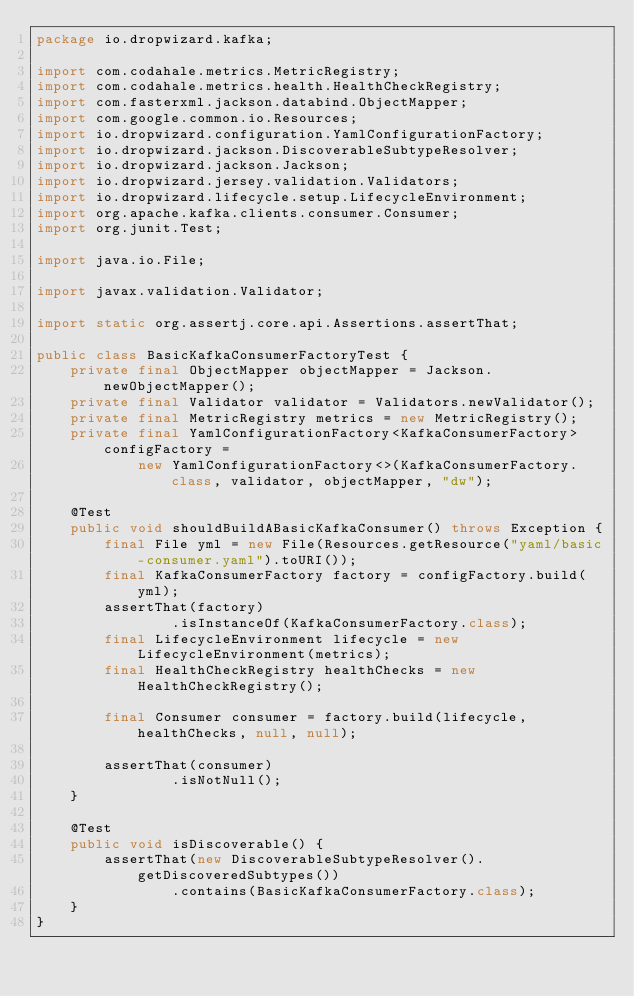Convert code to text. <code><loc_0><loc_0><loc_500><loc_500><_Java_>package io.dropwizard.kafka;

import com.codahale.metrics.MetricRegistry;
import com.codahale.metrics.health.HealthCheckRegistry;
import com.fasterxml.jackson.databind.ObjectMapper;
import com.google.common.io.Resources;
import io.dropwizard.configuration.YamlConfigurationFactory;
import io.dropwizard.jackson.DiscoverableSubtypeResolver;
import io.dropwizard.jackson.Jackson;
import io.dropwizard.jersey.validation.Validators;
import io.dropwizard.lifecycle.setup.LifecycleEnvironment;
import org.apache.kafka.clients.consumer.Consumer;
import org.junit.Test;

import java.io.File;

import javax.validation.Validator;

import static org.assertj.core.api.Assertions.assertThat;

public class BasicKafkaConsumerFactoryTest {
    private final ObjectMapper objectMapper = Jackson.newObjectMapper();
    private final Validator validator = Validators.newValidator();
    private final MetricRegistry metrics = new MetricRegistry();
    private final YamlConfigurationFactory<KafkaConsumerFactory> configFactory =
            new YamlConfigurationFactory<>(KafkaConsumerFactory.class, validator, objectMapper, "dw");

    @Test
    public void shouldBuildABasicKafkaConsumer() throws Exception {
        final File yml = new File(Resources.getResource("yaml/basic-consumer.yaml").toURI());
        final KafkaConsumerFactory factory = configFactory.build(yml);
        assertThat(factory)
                .isInstanceOf(KafkaConsumerFactory.class);
        final LifecycleEnvironment lifecycle = new LifecycleEnvironment(metrics);
        final HealthCheckRegistry healthChecks = new HealthCheckRegistry();

        final Consumer consumer = factory.build(lifecycle, healthChecks, null, null);

        assertThat(consumer)
                .isNotNull();
    }

    @Test
    public void isDiscoverable() {
        assertThat(new DiscoverableSubtypeResolver().getDiscoveredSubtypes())
                .contains(BasicKafkaConsumerFactory.class);
    }
}
</code> 